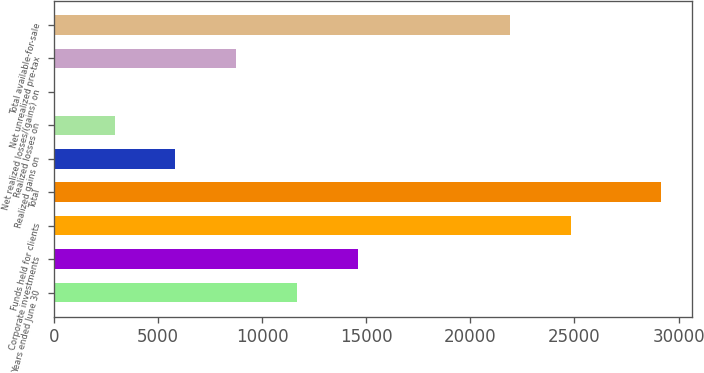<chart> <loc_0><loc_0><loc_500><loc_500><bar_chart><fcel>Years ended June 30<fcel>Corporate investments<fcel>Funds held for clients<fcel>Total<fcel>Realized gains on<fcel>Realized losses on<fcel>Net realized losses/(gains) on<fcel>Net unrealized pre-tax<fcel>Total available-for-sale<nl><fcel>11668<fcel>14584.5<fcel>24817.6<fcel>29166.8<fcel>5835.12<fcel>2918.66<fcel>2.2<fcel>8751.58<fcel>21901.1<nl></chart> 